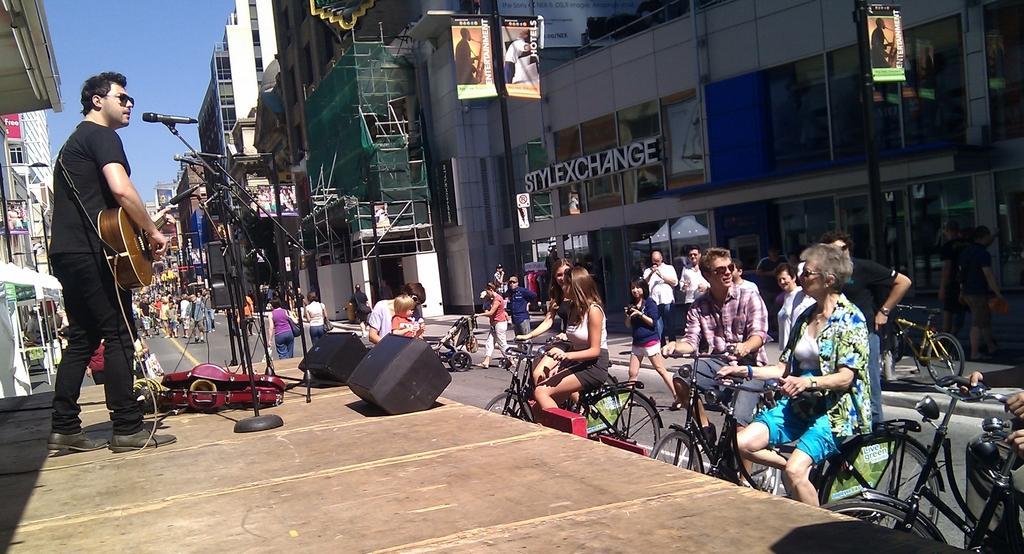Could you give a brief overview of what you see in this image? In this image we can see a road and some people are sitting on a bicycles which is parked and one person is playing a guitar and singing a song beside the road there is so many buildings and backside so many people are walking on the road. 